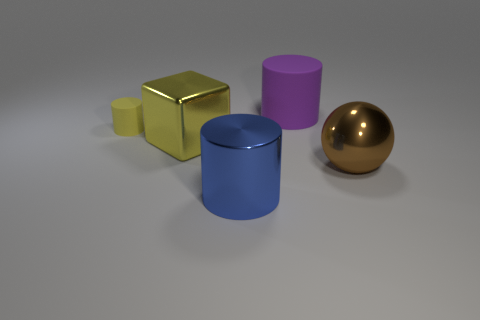Is there anything else that is the same size as the yellow rubber thing?
Provide a short and direct response. No. Are there the same number of purple objects that are in front of the yellow metal cube and metallic objects on the right side of the blue shiny cylinder?
Offer a terse response. No. Is the size of the yellow metallic block the same as the shiny thing that is right of the blue cylinder?
Your response must be concise. Yes. There is a large object right of the matte cylinder on the right side of the large blue cylinder; what is it made of?
Your response must be concise. Metal. Are there the same number of yellow things that are on the right side of the big yellow cube and big gray matte cubes?
Ensure brevity in your answer.  Yes. There is a object that is both in front of the large block and to the left of the ball; what is its size?
Give a very brief answer. Large. The metallic object that is to the left of the thing that is in front of the sphere is what color?
Keep it short and to the point. Yellow. What number of yellow objects are metallic blocks or tiny objects?
Offer a terse response. 2. What is the color of the cylinder that is behind the brown thing and on the right side of the yellow rubber object?
Offer a terse response. Purple. What number of tiny objects are either yellow things or cylinders?
Your response must be concise. 1. 